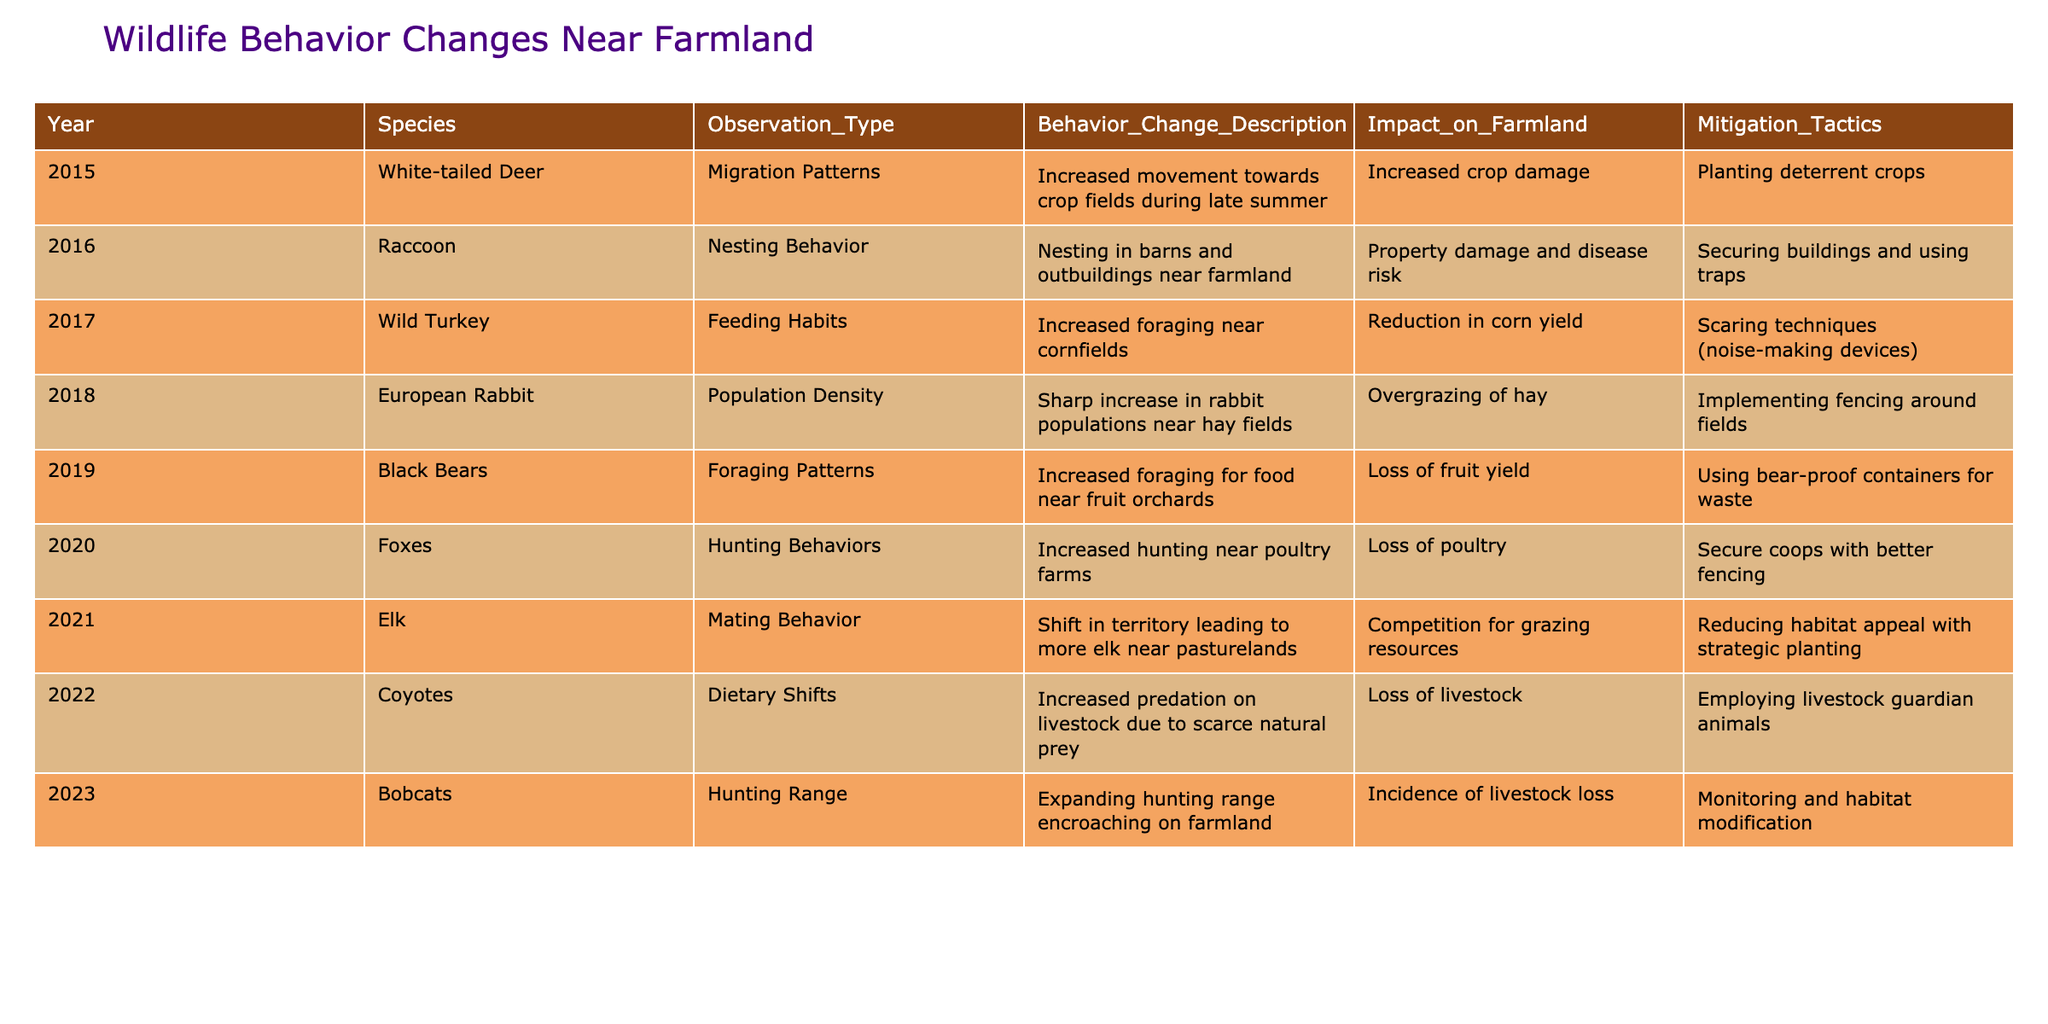What species had an increased movement towards crop fields in 2015? According to the table, in 2015, the White-tailed Deer had an increased movement towards crop fields during late summer, as noted under the observation type.
Answer: White-tailed Deer In which year did Raccoons start nesting in barns and outbuildings? The table shows that Raccoons exhibited nesting behavior near farmland in 2016.
Answer: 2016 What is the impact of the increased foraging patterns of Black Bears? The data indicates that the increased foraging patterns of Black Bears in 2019 led to a loss of fruit yield on farms.
Answer: Loss of fruit yield Which species has a behavioral change related to expanded hunting ranges? According to the table, Bobcats in 2023 showed an expanding hunting range encroaching on farmland.
Answer: Bobcats What mitigation tactic was suggested for Coyotes in 2022? The table lists employing livestock guardian animals as the mitigation tactic suggested for Coyotes due to increased predation on livestock.
Answer: Employing livestock guardian animals Which two species have been noted for changes in behavior affecting livestock? The table specifies that Coyotes in 2022 and Foxes in 2020 had behavior changes that affected livestock, indicating increased predation.
Answer: Coyotes and Foxes What was the total number of species observed for changes from 2015 to 2023? There are 9 unique species listed in the table from 2015 to 2023.
Answer: 9 Which year experienced the most types of observations listed? By reviewing the table, each year has only one observation type listed, not allowing comparison between years; however, the highest year count for recorded changes is 2023, with it marked for hunting range.
Answer: 2023 Can you name any year when European Rabbits showed behavior changes due to population density? The table reveals that in 2018, European Rabbits presented a sharp increase in population density near hay fields.
Answer: 2018 What was the impact of the increased foraging near fruit orchards as noted in the year 2019? The increased foraging patterns of Black Bears in 2019 resulted in a loss of fruit yield on farms, as per their observations.
Answer: Loss of fruit yield What observation type was reported for Elk behavior changes in 2021? The table indicates that Elk had a significant change in mating behavior noted in 2021, affecting their territory near pasturelands.
Answer: Mating Behavior 